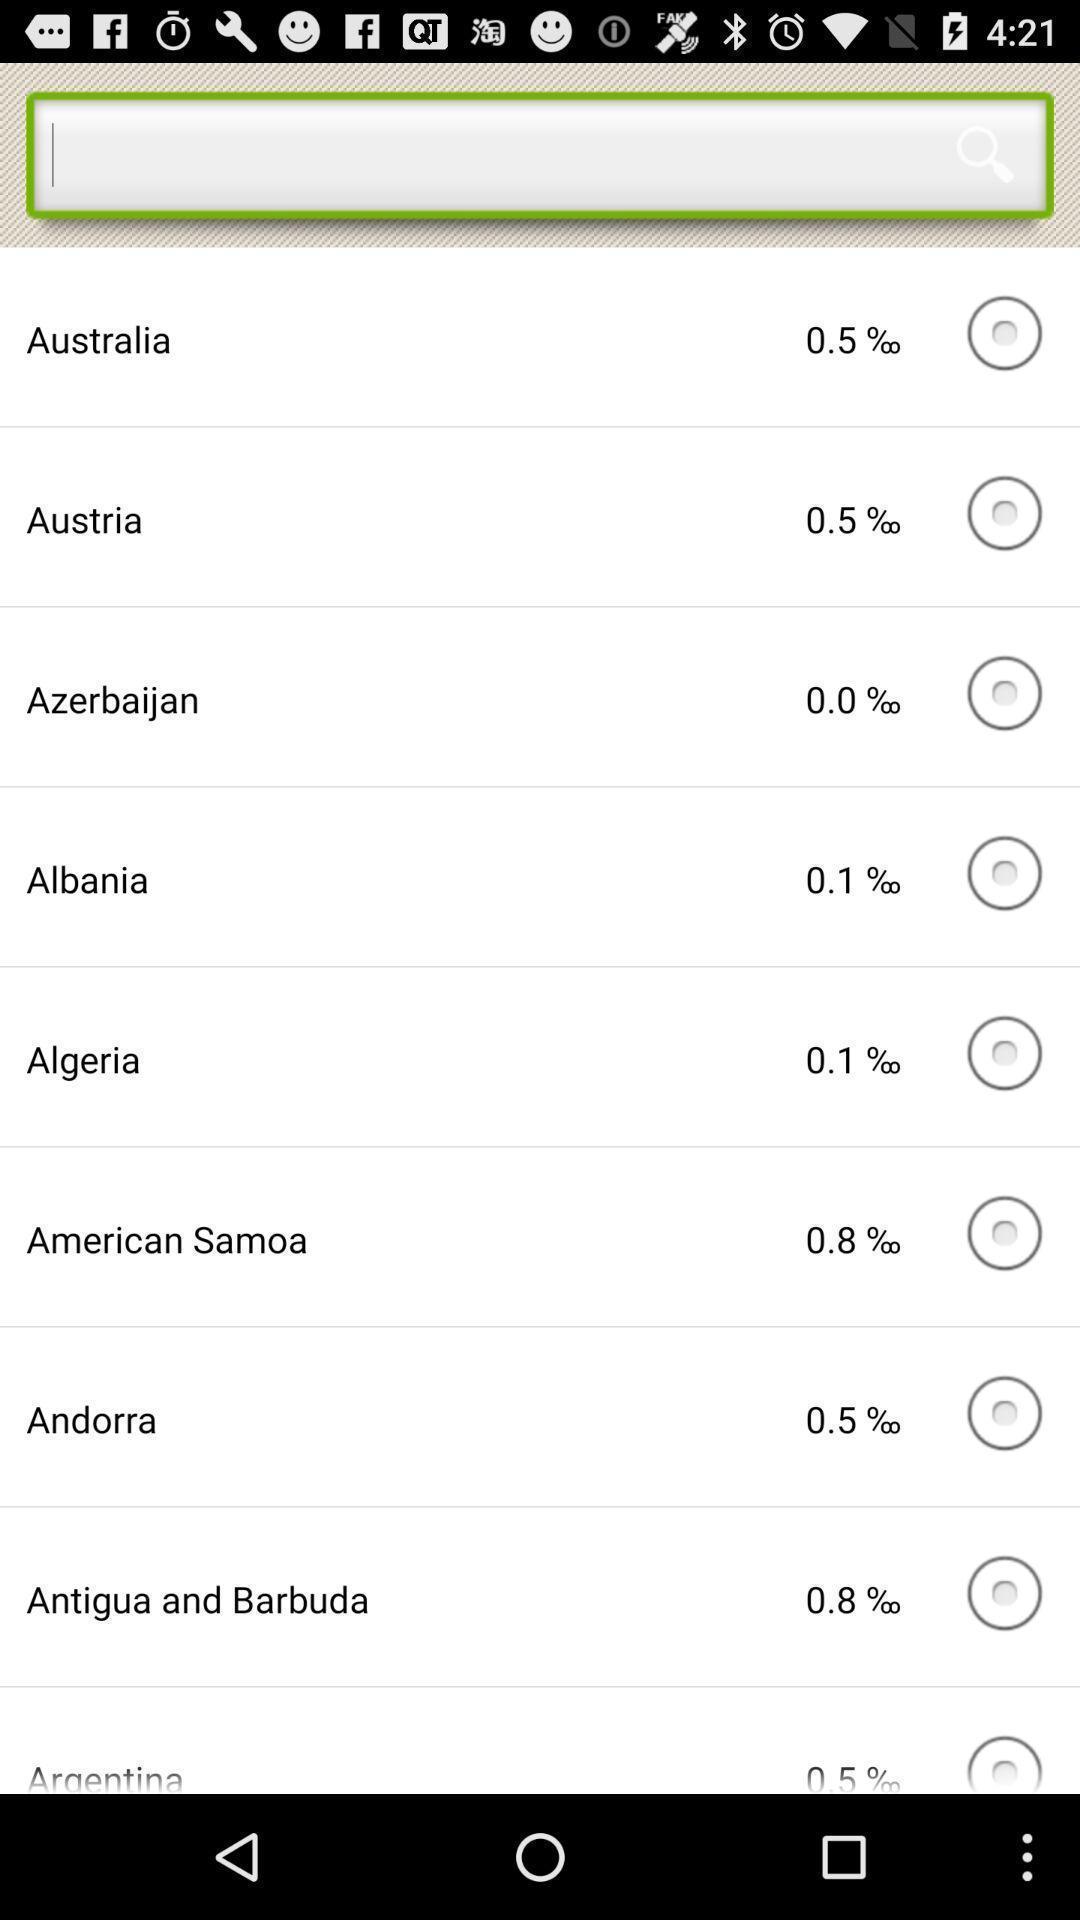Give me a narrative description of this picture. Page showing calculations on breathalyzer. 